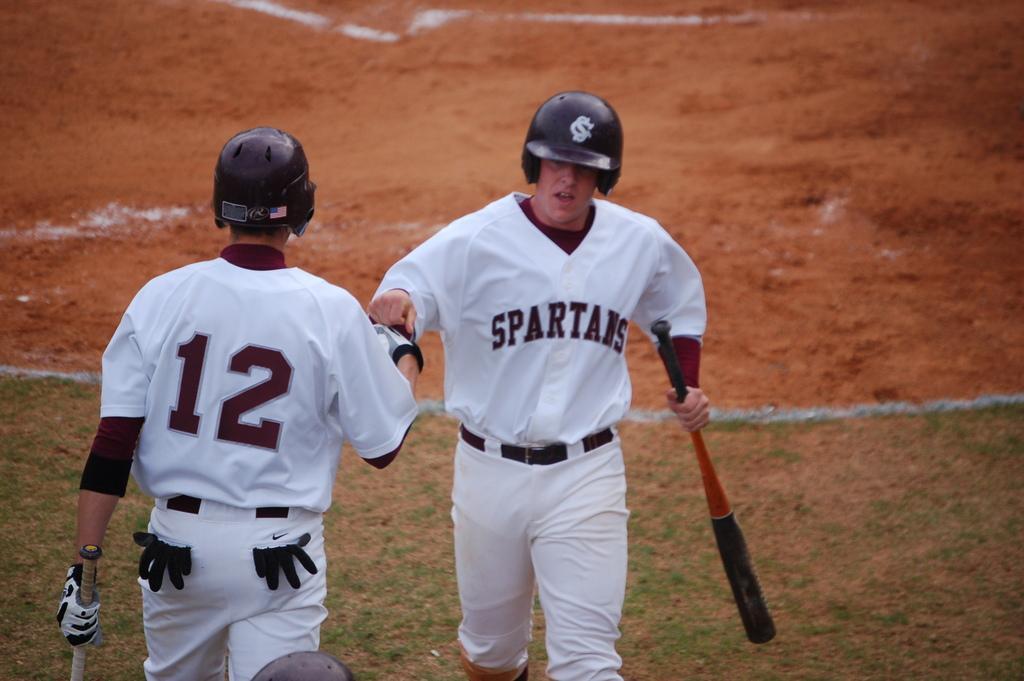Could you give a brief overview of what you see in this image? There are two men holding the baseball bats and walking. I think this is the ground. 